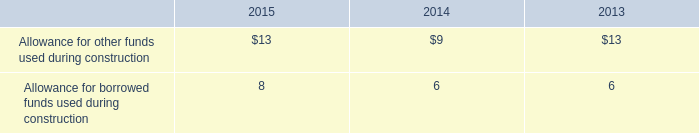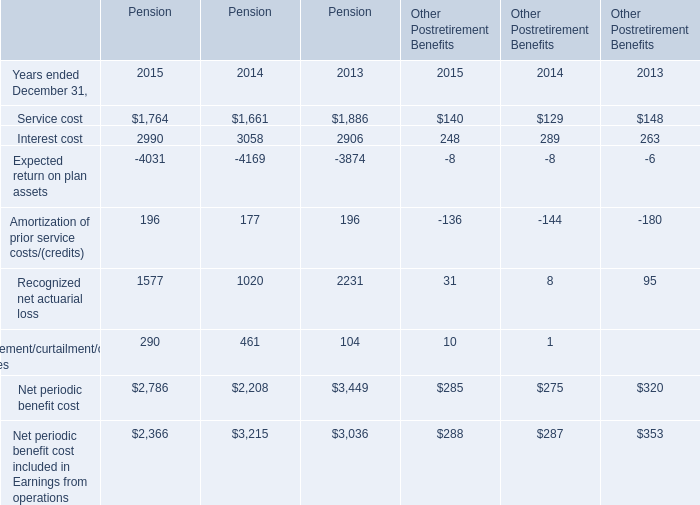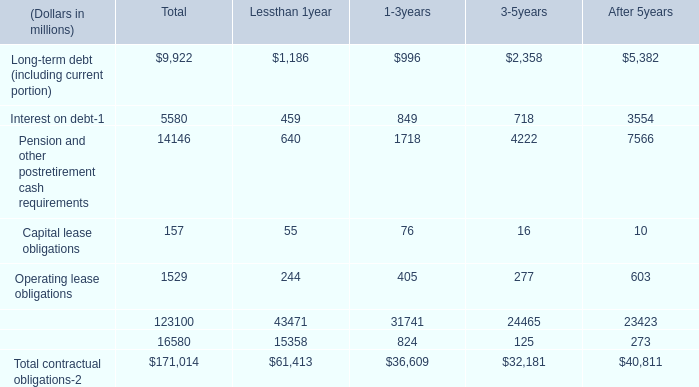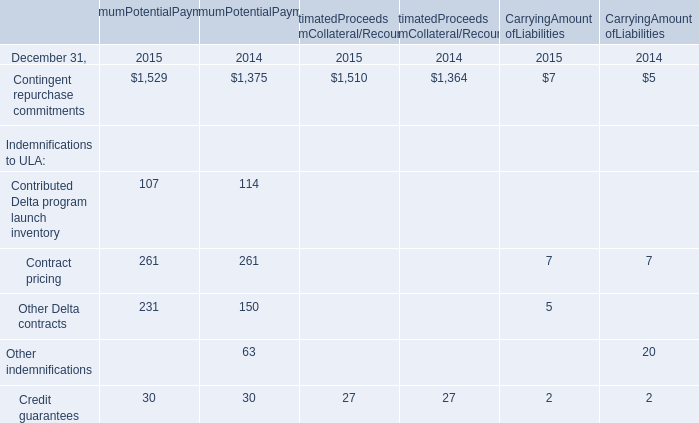In which section the sum of Service cost has the highest value? 
Answer: Pension. 